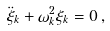Convert formula to latex. <formula><loc_0><loc_0><loc_500><loc_500>\ddot { \xi } _ { k } + \omega _ { k } ^ { 2 } \xi _ { k } = 0 \, ,</formula> 